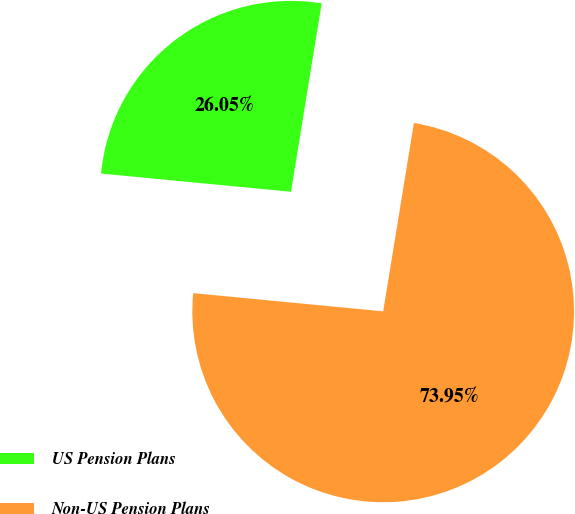Convert chart to OTSL. <chart><loc_0><loc_0><loc_500><loc_500><pie_chart><fcel>US Pension Plans<fcel>Non-US Pension Plans<nl><fcel>26.05%<fcel>73.95%<nl></chart> 